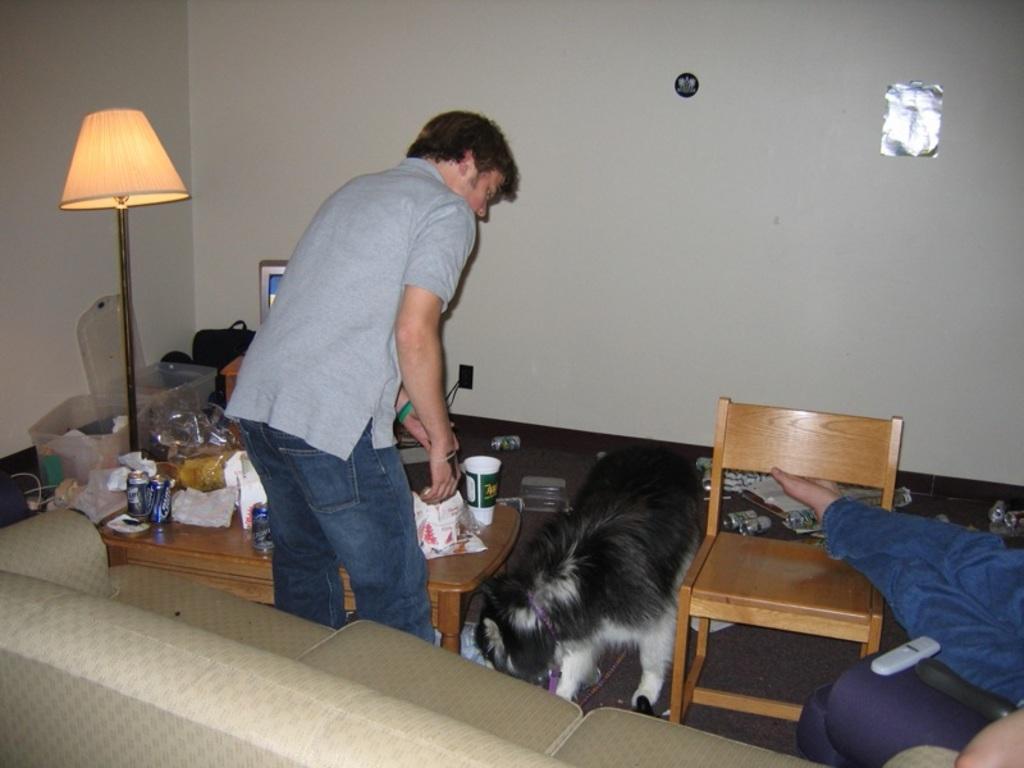Please provide a concise description of this image. In this image i can see a person standing wearing ash color shirt and jeans, a dog is laying on the floor inn black and white color at right there is a chair at left there are few covers, a lamp,a bag, a frame on the table. At the background i can see a wall at front there is a couch in cream color. 